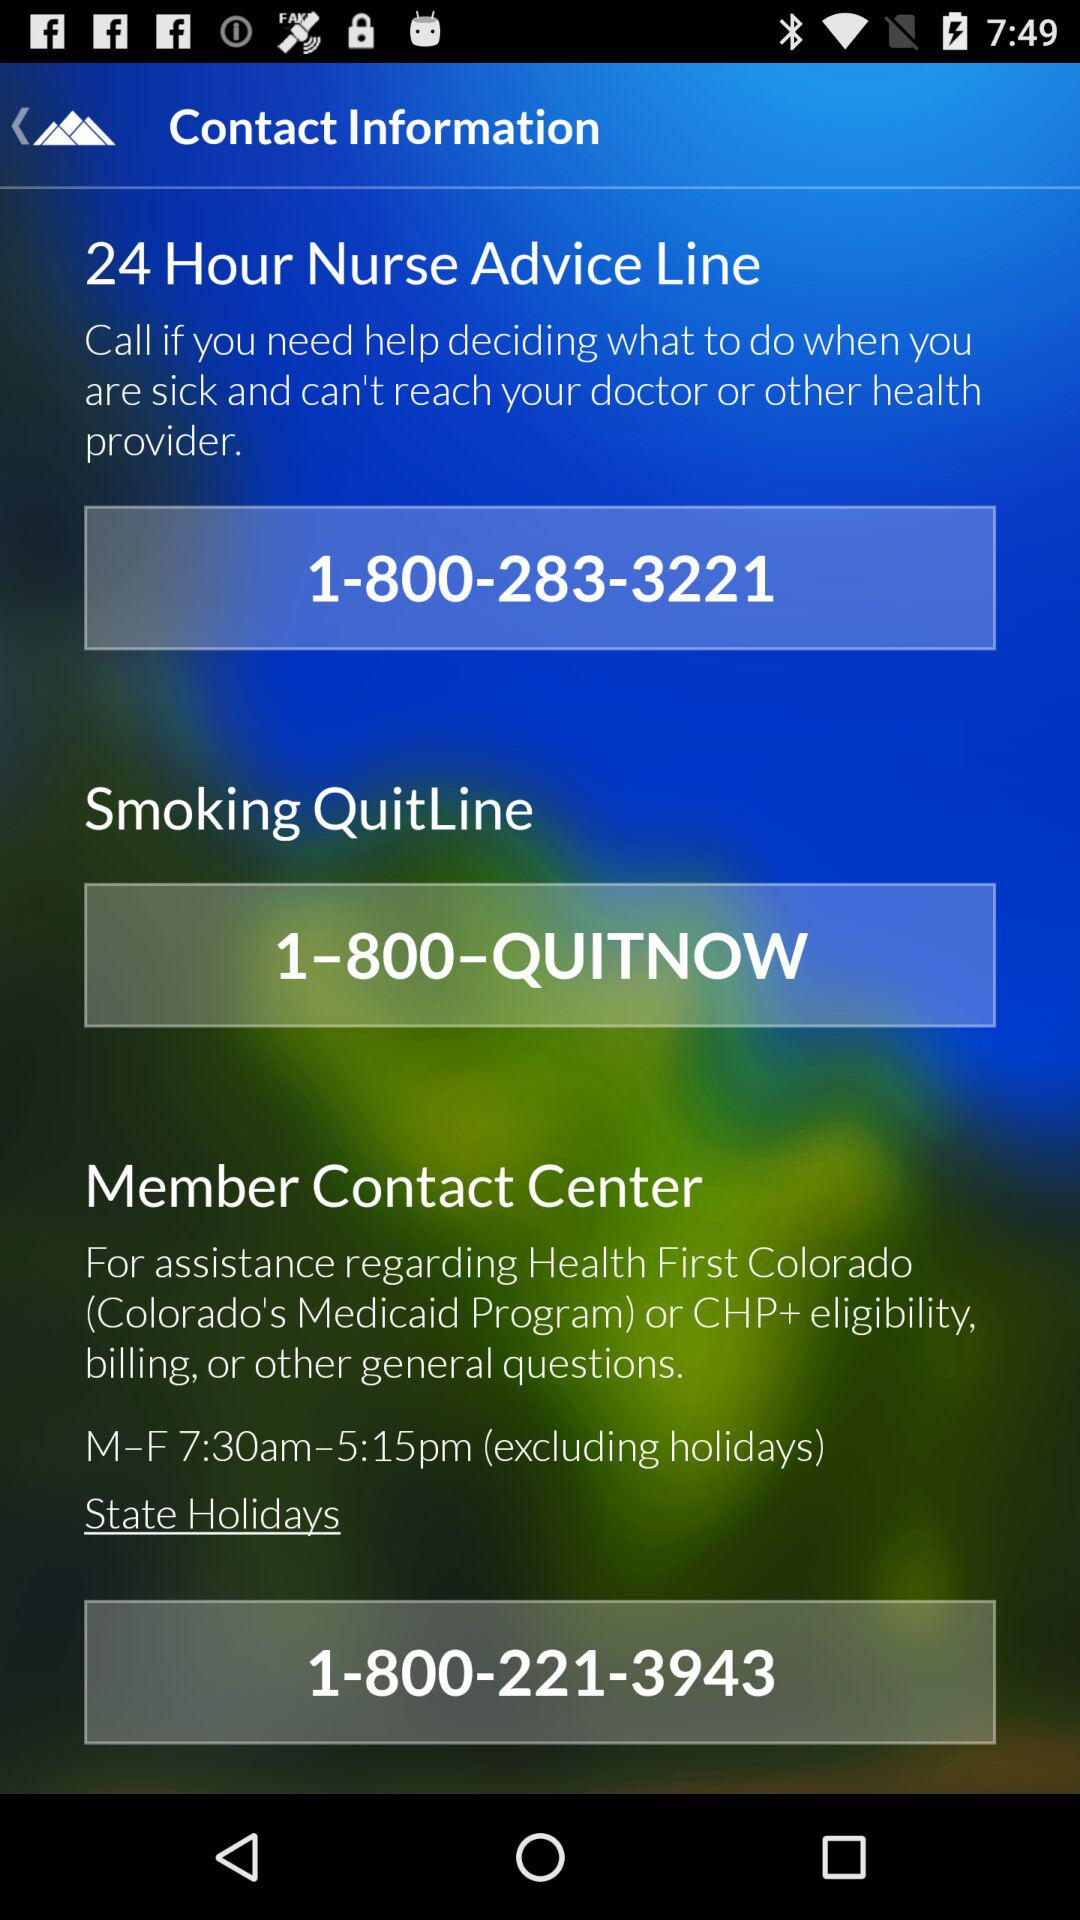What is the contact number for the "Member Contact Center"? The contact number is 1-800-221-3943. 